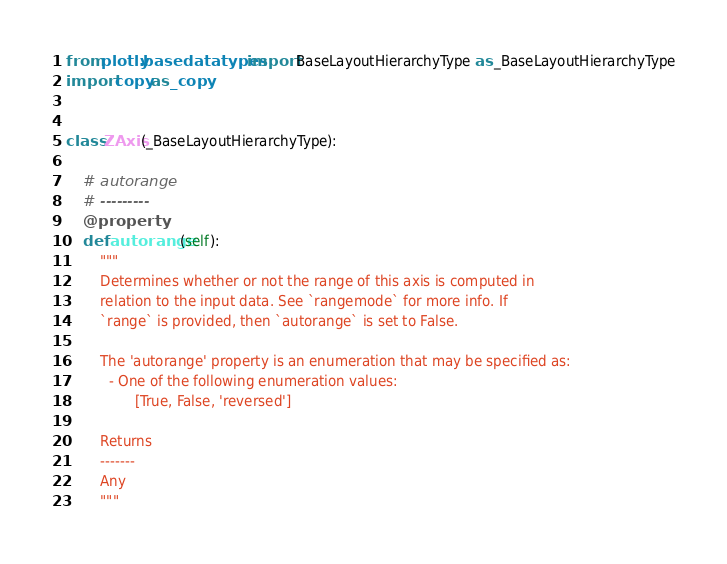Convert code to text. <code><loc_0><loc_0><loc_500><loc_500><_Python_>from plotly.basedatatypes import BaseLayoutHierarchyType as _BaseLayoutHierarchyType
import copy as _copy


class ZAxis(_BaseLayoutHierarchyType):

    # autorange
    # ---------
    @property
    def autorange(self):
        """
        Determines whether or not the range of this axis is computed in
        relation to the input data. See `rangemode` for more info. If
        `range` is provided, then `autorange` is set to False.
    
        The 'autorange' property is an enumeration that may be specified as:
          - One of the following enumeration values:
                [True, False, 'reversed']

        Returns
        -------
        Any
        """</code> 